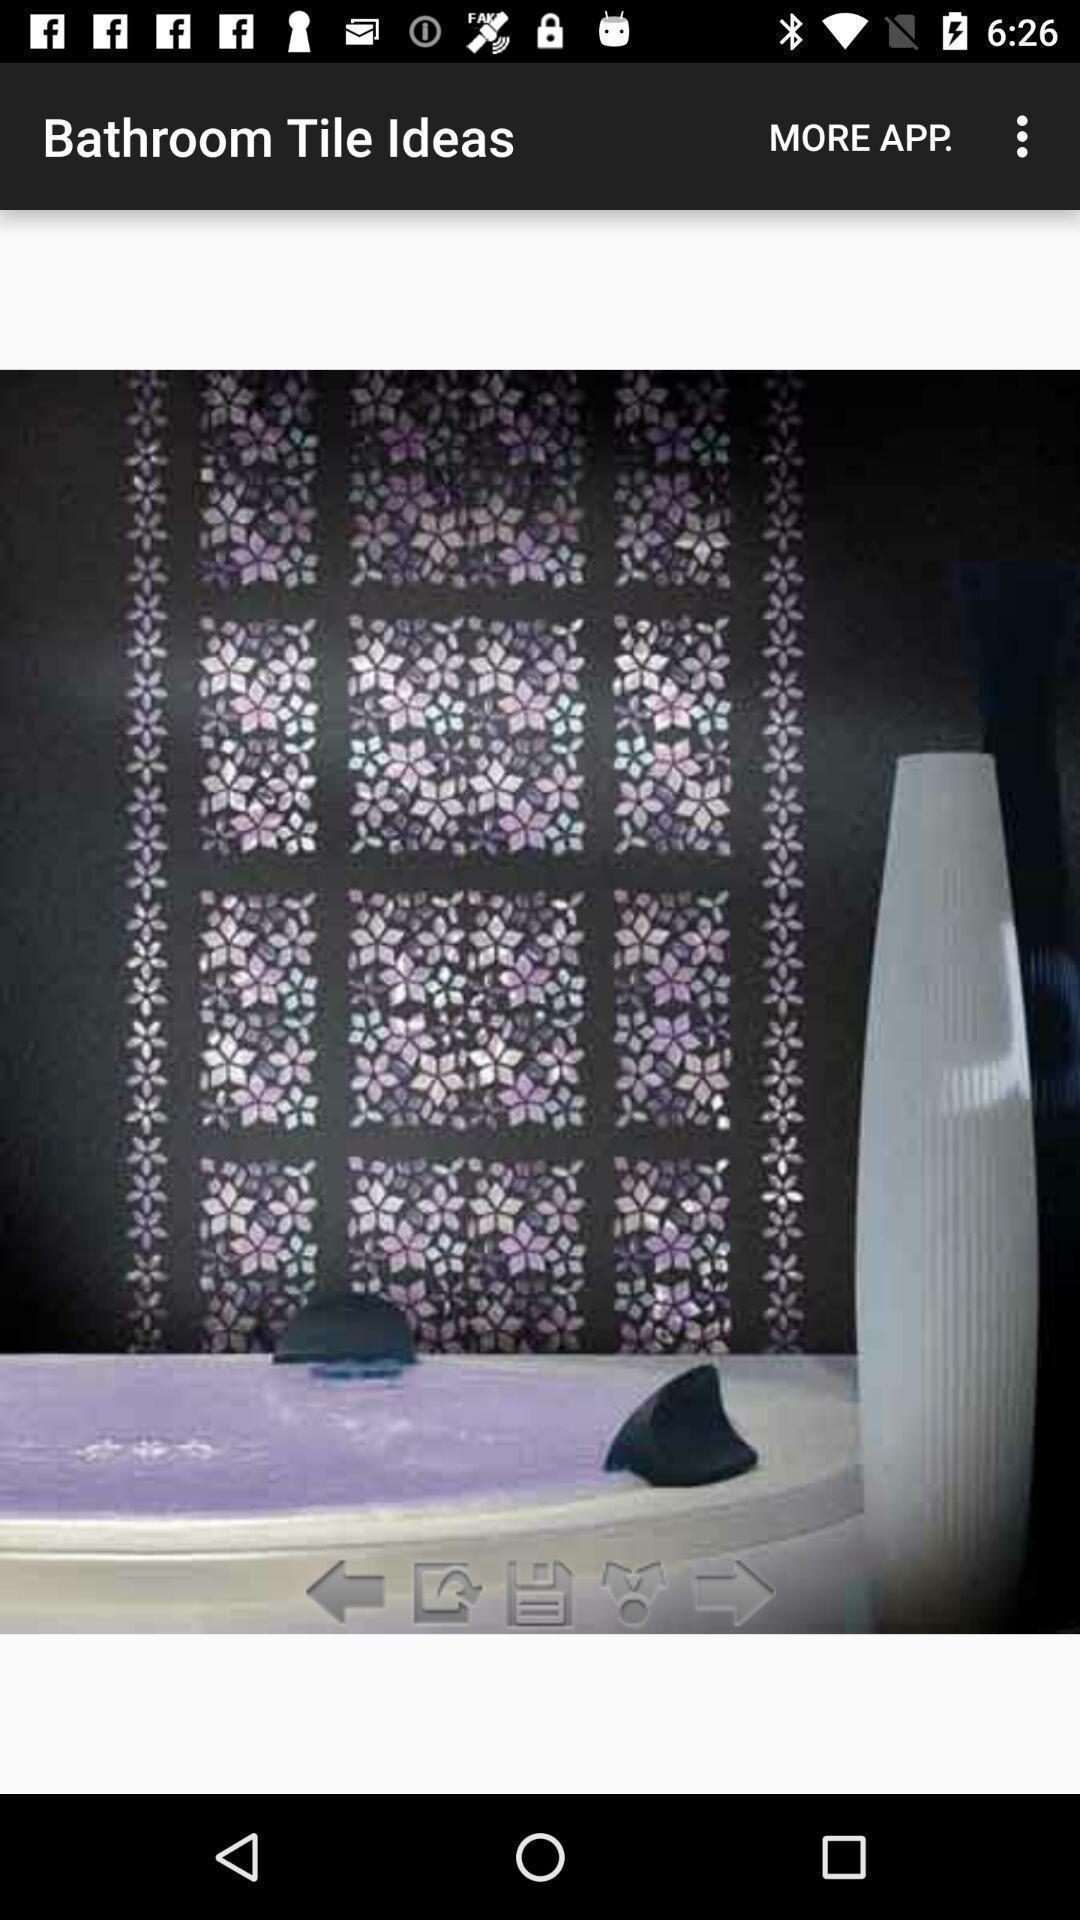Provide a description of this screenshot. Page shows a picture in the house decoration app. 